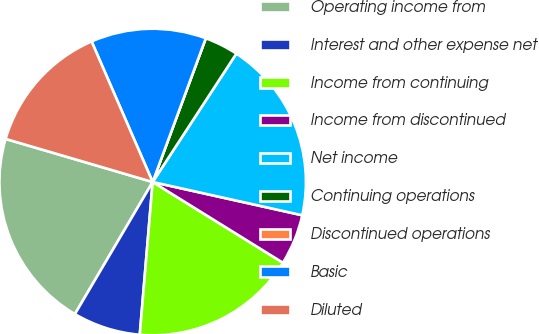<chart> <loc_0><loc_0><loc_500><loc_500><pie_chart><fcel>Operating income from<fcel>Interest and other expense net<fcel>Income from continuing<fcel>Income from discontinued<fcel>Net income<fcel>Continuing operations<fcel>Discontinued operations<fcel>Basic<fcel>Diluted<nl><fcel>21.07%<fcel>7.13%<fcel>17.51%<fcel>5.35%<fcel>19.29%<fcel>3.56%<fcel>0.0%<fcel>12.16%<fcel>13.94%<nl></chart> 